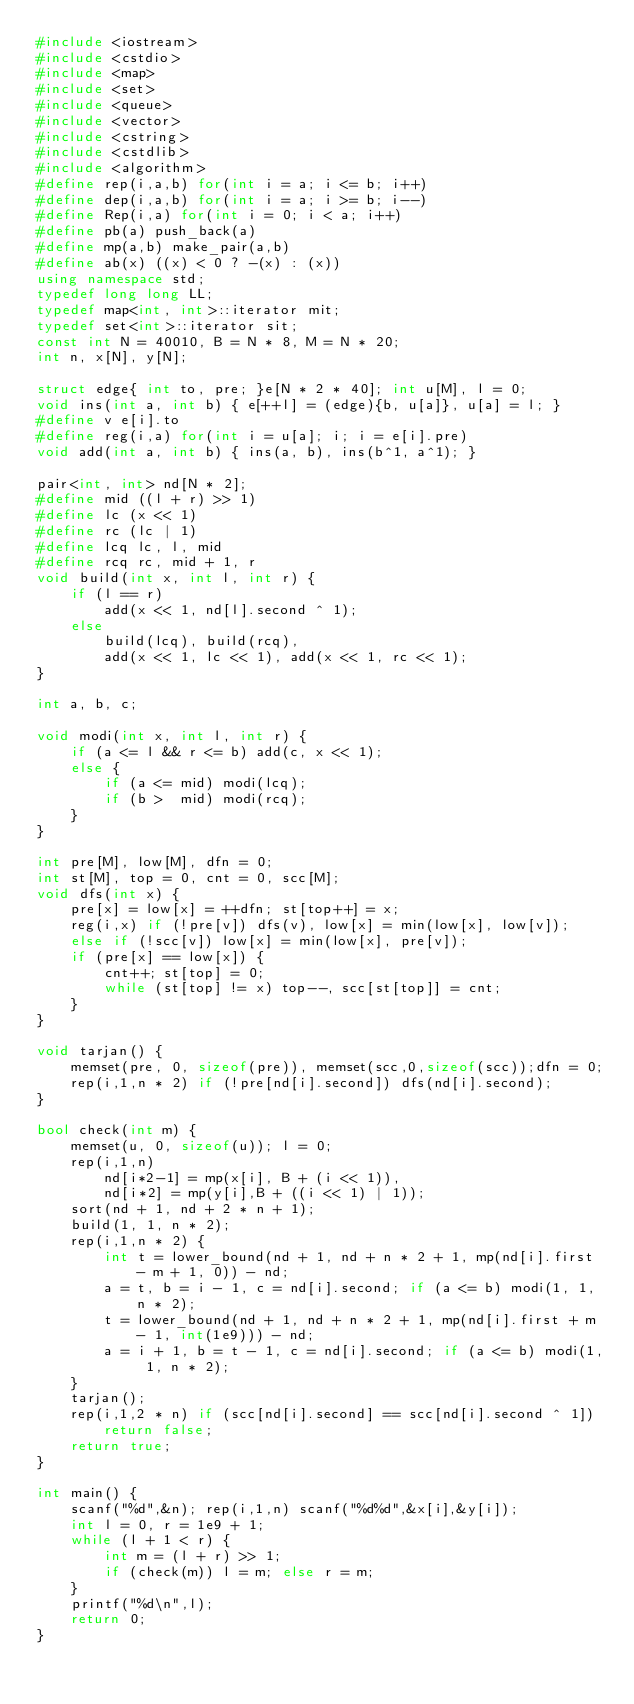Convert code to text. <code><loc_0><loc_0><loc_500><loc_500><_C++_>#include <iostream>
#include <cstdio>
#include <map>
#include <set>
#include <queue>
#include <vector>
#include <cstring>
#include <cstdlib>
#include <algorithm>
#define rep(i,a,b) for(int i = a; i <= b; i++)
#define dep(i,a,b) for(int i = a; i >= b; i--) 
#define Rep(i,a) for(int i = 0; i < a; i++)
#define pb(a) push_back(a)
#define mp(a,b) make_pair(a,b)
#define ab(x) ((x) < 0 ? -(x) : (x))
using namespace std;
typedef long long LL;
typedef map<int, int>::iterator mit;
typedef set<int>::iterator sit;
const int N = 40010, B = N * 8, M = N * 20;
int n, x[N], y[N];
 
struct edge{ int to, pre; }e[N * 2 * 40]; int u[M], l = 0;
void ins(int a, int b) { e[++l] = (edge){b, u[a]}, u[a] = l; }
#define v e[i].to
#define reg(i,a) for(int i = u[a]; i; i = e[i].pre)
void add(int a, int b) { ins(a, b), ins(b^1, a^1); }
 
pair<int, int> nd[N * 2];
#define mid ((l + r) >> 1)
#define lc (x << 1)
#define rc (lc | 1)
#define lcq lc, l, mid
#define rcq rc, mid + 1, r
void build(int x, int l, int r) {
	if (l == r) 
		add(x << 1, nd[l].second ^ 1); 
	else 
		build(lcq), build(rcq), 
		add(x << 1, lc << 1), add(x << 1, rc << 1);
}
 
int a, b, c;
 
void modi(int x, int l, int r) {
	if (a <= l && r <= b) add(c, x << 1);
	else {
		if (a <= mid) modi(lcq); 
		if (b >  mid) modi(rcq);
	}
}
 
int pre[M], low[M], dfn = 0; 
int st[M], top = 0, cnt = 0, scc[M];
void dfs(int x) {
	pre[x] = low[x] = ++dfn; st[top++] = x;
	reg(i,x) if (!pre[v]) dfs(v), low[x] = min(low[x], low[v]);
	else if (!scc[v]) low[x] = min(low[x], pre[v]);
	if (pre[x] == low[x]) {
		cnt++; st[top] = 0;
		while (st[top] != x) top--, scc[st[top]] = cnt;
	}
}
 
void tarjan() {
	memset(pre, 0, sizeof(pre)), memset(scc,0,sizeof(scc));dfn = 0;
	rep(i,1,n * 2) if (!pre[nd[i].second]) dfs(nd[i].second);
}
 
bool check(int m) {
	memset(u, 0, sizeof(u)); l = 0;
	rep(i,1,n) 
		nd[i*2-1] = mp(x[i], B + (i << 1)), 
		nd[i*2] = mp(y[i],B + ((i << 1) | 1));
	sort(nd + 1, nd + 2 * n + 1);
	build(1, 1, n * 2);
	rep(i,1,n * 2) {
		int t = lower_bound(nd + 1, nd + n * 2 + 1, mp(nd[i].first - m + 1, 0)) - nd;
		a = t, b = i - 1, c = nd[i].second; if (a <= b) modi(1, 1, n * 2);
		t = lower_bound(nd + 1, nd + n * 2 + 1, mp(nd[i].first + m - 1, int(1e9))) - nd;
		a = i + 1, b = t - 1, c = nd[i].second; if (a <= b) modi(1, 1, n * 2);
	}
	tarjan();
	rep(i,1,2 * n) if (scc[nd[i].second] == scc[nd[i].second ^ 1]) return false;
	return true;
}
 
int main() {
	scanf("%d",&n); rep(i,1,n) scanf("%d%d",&x[i],&y[i]);
	int l = 0, r = 1e9 + 1;
	while (l + 1 < r) {
		int m = (l + r) >> 1;
		if (check(m)) l = m; else r = m;
	}
	printf("%d\n",l);
	return 0;
}</code> 